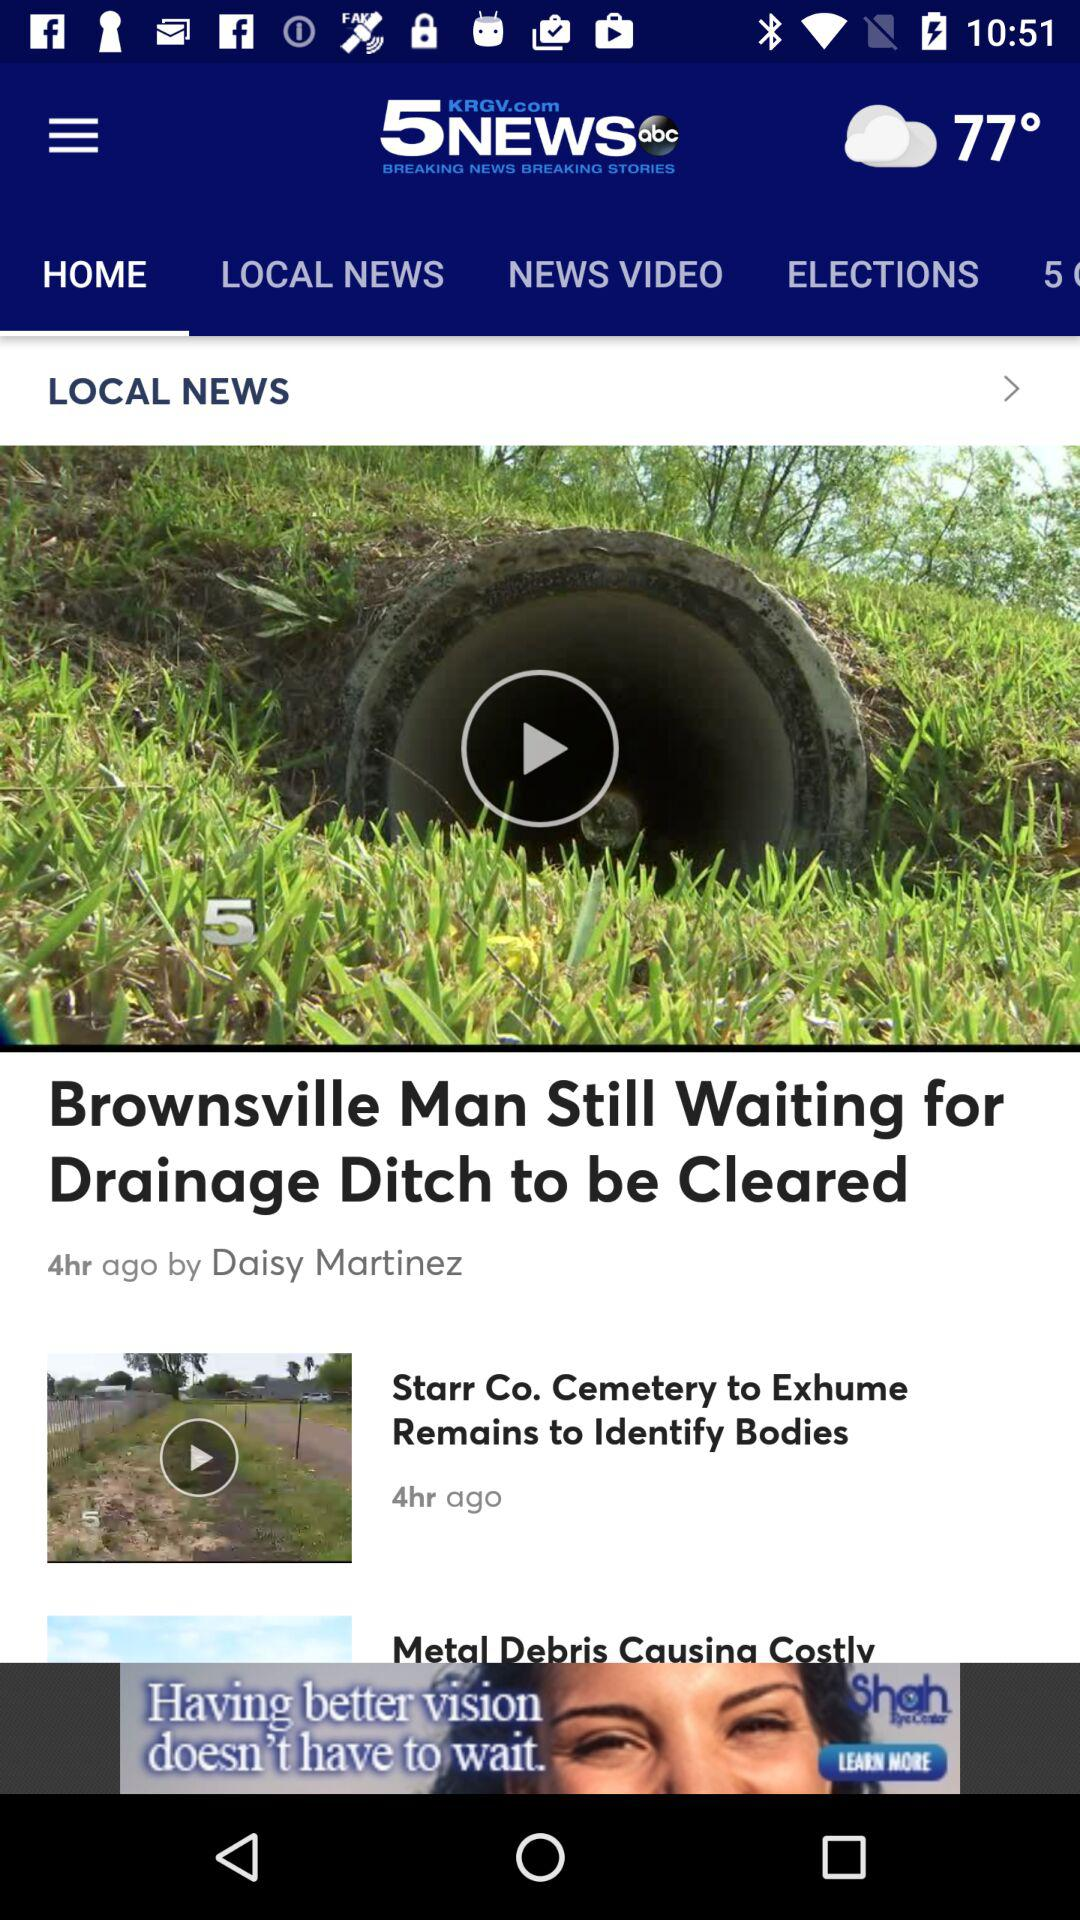How many hours ago was the article about the drainage ditch cleared?
Answer the question using a single word or phrase. 4 